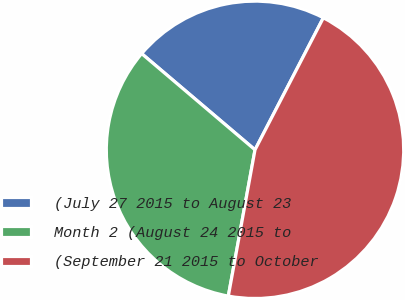Convert chart. <chart><loc_0><loc_0><loc_500><loc_500><pie_chart><fcel>(July 27 2015 to August 23<fcel>Month 2 (August 24 2015 to<fcel>(September 21 2015 to October<nl><fcel>21.4%<fcel>33.33%<fcel>45.27%<nl></chart> 